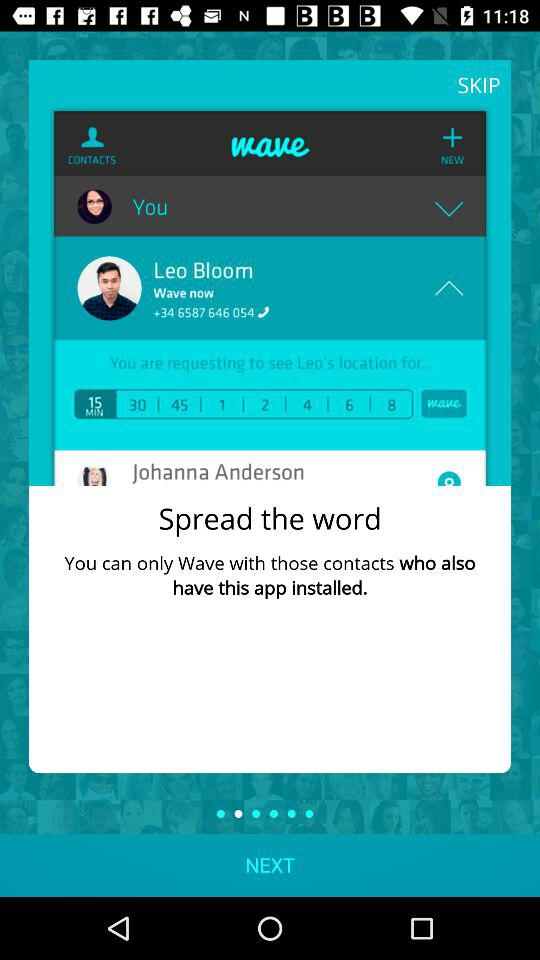What is the application name? The name of the application is "wave". 